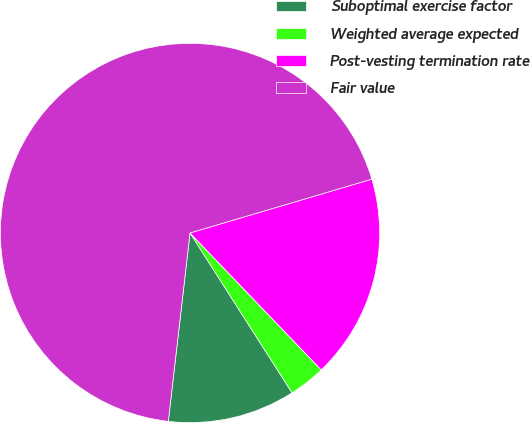<chart> <loc_0><loc_0><loc_500><loc_500><pie_chart><fcel>Suboptimal exercise factor<fcel>Weighted average expected<fcel>Post-vesting termination rate<fcel>Fair value<nl><fcel>10.87%<fcel>3.12%<fcel>17.42%<fcel>68.59%<nl></chart> 